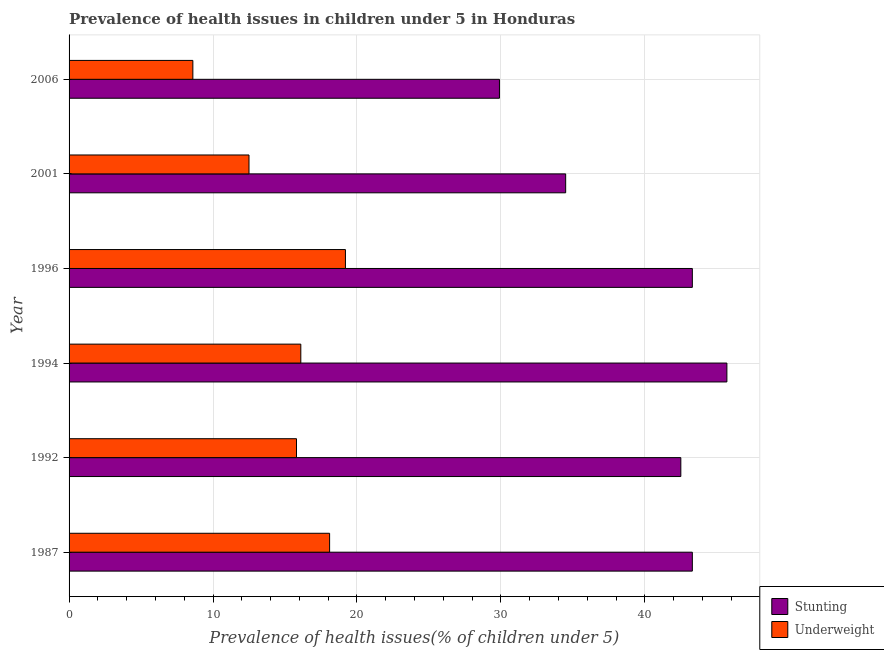Are the number of bars on each tick of the Y-axis equal?
Your answer should be very brief. Yes. How many bars are there on the 4th tick from the top?
Give a very brief answer. 2. How many bars are there on the 6th tick from the bottom?
Offer a very short reply. 2. What is the label of the 2nd group of bars from the top?
Give a very brief answer. 2001. What is the percentage of stunted children in 1987?
Make the answer very short. 43.3. Across all years, what is the maximum percentage of stunted children?
Make the answer very short. 45.7. Across all years, what is the minimum percentage of stunted children?
Provide a succinct answer. 29.9. In which year was the percentage of stunted children maximum?
Provide a succinct answer. 1994. What is the total percentage of underweight children in the graph?
Your answer should be compact. 90.3. What is the difference between the percentage of stunted children in 1996 and the percentage of underweight children in 1987?
Give a very brief answer. 25.2. What is the average percentage of stunted children per year?
Provide a short and direct response. 39.87. In the year 1996, what is the difference between the percentage of stunted children and percentage of underweight children?
Offer a very short reply. 24.1. In how many years, is the percentage of stunted children greater than 32 %?
Make the answer very short. 5. What is the ratio of the percentage of underweight children in 1987 to that in 1994?
Provide a succinct answer. 1.12. Is the difference between the percentage of stunted children in 1987 and 2001 greater than the difference between the percentage of underweight children in 1987 and 2001?
Make the answer very short. Yes. Is the sum of the percentage of underweight children in 1992 and 1994 greater than the maximum percentage of stunted children across all years?
Your response must be concise. No. What does the 1st bar from the top in 1987 represents?
Provide a succinct answer. Underweight. What does the 2nd bar from the bottom in 1987 represents?
Your response must be concise. Underweight. How many years are there in the graph?
Provide a succinct answer. 6. What is the difference between two consecutive major ticks on the X-axis?
Provide a short and direct response. 10. Are the values on the major ticks of X-axis written in scientific E-notation?
Offer a very short reply. No. Does the graph contain grids?
Your answer should be very brief. Yes. Where does the legend appear in the graph?
Keep it short and to the point. Bottom right. How many legend labels are there?
Offer a terse response. 2. How are the legend labels stacked?
Offer a very short reply. Vertical. What is the title of the graph?
Give a very brief answer. Prevalence of health issues in children under 5 in Honduras. What is the label or title of the X-axis?
Make the answer very short. Prevalence of health issues(% of children under 5). What is the label or title of the Y-axis?
Offer a very short reply. Year. What is the Prevalence of health issues(% of children under 5) in Stunting in 1987?
Your response must be concise. 43.3. What is the Prevalence of health issues(% of children under 5) in Underweight in 1987?
Offer a terse response. 18.1. What is the Prevalence of health issues(% of children under 5) of Stunting in 1992?
Give a very brief answer. 42.5. What is the Prevalence of health issues(% of children under 5) in Underweight in 1992?
Offer a terse response. 15.8. What is the Prevalence of health issues(% of children under 5) of Stunting in 1994?
Your response must be concise. 45.7. What is the Prevalence of health issues(% of children under 5) in Underweight in 1994?
Provide a succinct answer. 16.1. What is the Prevalence of health issues(% of children under 5) in Stunting in 1996?
Keep it short and to the point. 43.3. What is the Prevalence of health issues(% of children under 5) in Underweight in 1996?
Provide a short and direct response. 19.2. What is the Prevalence of health issues(% of children under 5) of Stunting in 2001?
Keep it short and to the point. 34.5. What is the Prevalence of health issues(% of children under 5) of Stunting in 2006?
Provide a short and direct response. 29.9. What is the Prevalence of health issues(% of children under 5) of Underweight in 2006?
Make the answer very short. 8.6. Across all years, what is the maximum Prevalence of health issues(% of children under 5) in Stunting?
Provide a succinct answer. 45.7. Across all years, what is the maximum Prevalence of health issues(% of children under 5) in Underweight?
Offer a terse response. 19.2. Across all years, what is the minimum Prevalence of health issues(% of children under 5) in Stunting?
Offer a terse response. 29.9. Across all years, what is the minimum Prevalence of health issues(% of children under 5) in Underweight?
Provide a succinct answer. 8.6. What is the total Prevalence of health issues(% of children under 5) in Stunting in the graph?
Provide a succinct answer. 239.2. What is the total Prevalence of health issues(% of children under 5) of Underweight in the graph?
Keep it short and to the point. 90.3. What is the difference between the Prevalence of health issues(% of children under 5) in Stunting in 1987 and that in 1996?
Your answer should be very brief. 0. What is the difference between the Prevalence of health issues(% of children under 5) of Underweight in 1992 and that in 1994?
Provide a succinct answer. -0.3. What is the difference between the Prevalence of health issues(% of children under 5) in Stunting in 1992 and that in 1996?
Ensure brevity in your answer.  -0.8. What is the difference between the Prevalence of health issues(% of children under 5) of Stunting in 1992 and that in 2001?
Offer a terse response. 8. What is the difference between the Prevalence of health issues(% of children under 5) of Underweight in 1992 and that in 2006?
Offer a terse response. 7.2. What is the difference between the Prevalence of health issues(% of children under 5) of Stunting in 1994 and that in 2001?
Keep it short and to the point. 11.2. What is the difference between the Prevalence of health issues(% of children under 5) in Underweight in 1994 and that in 2006?
Keep it short and to the point. 7.5. What is the difference between the Prevalence of health issues(% of children under 5) of Stunting in 1996 and that in 2001?
Make the answer very short. 8.8. What is the difference between the Prevalence of health issues(% of children under 5) of Underweight in 1996 and that in 2001?
Give a very brief answer. 6.7. What is the difference between the Prevalence of health issues(% of children under 5) in Stunting in 2001 and that in 2006?
Your response must be concise. 4.6. What is the difference between the Prevalence of health issues(% of children under 5) of Stunting in 1987 and the Prevalence of health issues(% of children under 5) of Underweight in 1994?
Your answer should be compact. 27.2. What is the difference between the Prevalence of health issues(% of children under 5) in Stunting in 1987 and the Prevalence of health issues(% of children under 5) in Underweight in 1996?
Provide a short and direct response. 24.1. What is the difference between the Prevalence of health issues(% of children under 5) of Stunting in 1987 and the Prevalence of health issues(% of children under 5) of Underweight in 2001?
Offer a terse response. 30.8. What is the difference between the Prevalence of health issues(% of children under 5) of Stunting in 1987 and the Prevalence of health issues(% of children under 5) of Underweight in 2006?
Make the answer very short. 34.7. What is the difference between the Prevalence of health issues(% of children under 5) in Stunting in 1992 and the Prevalence of health issues(% of children under 5) in Underweight in 1994?
Offer a very short reply. 26.4. What is the difference between the Prevalence of health issues(% of children under 5) of Stunting in 1992 and the Prevalence of health issues(% of children under 5) of Underweight in 1996?
Your answer should be compact. 23.3. What is the difference between the Prevalence of health issues(% of children under 5) in Stunting in 1992 and the Prevalence of health issues(% of children under 5) in Underweight in 2006?
Give a very brief answer. 33.9. What is the difference between the Prevalence of health issues(% of children under 5) in Stunting in 1994 and the Prevalence of health issues(% of children under 5) in Underweight in 2001?
Give a very brief answer. 33.2. What is the difference between the Prevalence of health issues(% of children under 5) in Stunting in 1994 and the Prevalence of health issues(% of children under 5) in Underweight in 2006?
Make the answer very short. 37.1. What is the difference between the Prevalence of health issues(% of children under 5) in Stunting in 1996 and the Prevalence of health issues(% of children under 5) in Underweight in 2001?
Your response must be concise. 30.8. What is the difference between the Prevalence of health issues(% of children under 5) of Stunting in 1996 and the Prevalence of health issues(% of children under 5) of Underweight in 2006?
Your answer should be compact. 34.7. What is the difference between the Prevalence of health issues(% of children under 5) of Stunting in 2001 and the Prevalence of health issues(% of children under 5) of Underweight in 2006?
Your answer should be very brief. 25.9. What is the average Prevalence of health issues(% of children under 5) of Stunting per year?
Ensure brevity in your answer.  39.87. What is the average Prevalence of health issues(% of children under 5) in Underweight per year?
Make the answer very short. 15.05. In the year 1987, what is the difference between the Prevalence of health issues(% of children under 5) of Stunting and Prevalence of health issues(% of children under 5) of Underweight?
Keep it short and to the point. 25.2. In the year 1992, what is the difference between the Prevalence of health issues(% of children under 5) of Stunting and Prevalence of health issues(% of children under 5) of Underweight?
Give a very brief answer. 26.7. In the year 1994, what is the difference between the Prevalence of health issues(% of children under 5) in Stunting and Prevalence of health issues(% of children under 5) in Underweight?
Give a very brief answer. 29.6. In the year 1996, what is the difference between the Prevalence of health issues(% of children under 5) of Stunting and Prevalence of health issues(% of children under 5) of Underweight?
Give a very brief answer. 24.1. In the year 2001, what is the difference between the Prevalence of health issues(% of children under 5) of Stunting and Prevalence of health issues(% of children under 5) of Underweight?
Ensure brevity in your answer.  22. In the year 2006, what is the difference between the Prevalence of health issues(% of children under 5) of Stunting and Prevalence of health issues(% of children under 5) of Underweight?
Keep it short and to the point. 21.3. What is the ratio of the Prevalence of health issues(% of children under 5) in Stunting in 1987 to that in 1992?
Offer a very short reply. 1.02. What is the ratio of the Prevalence of health issues(% of children under 5) of Underweight in 1987 to that in 1992?
Your response must be concise. 1.15. What is the ratio of the Prevalence of health issues(% of children under 5) of Stunting in 1987 to that in 1994?
Your answer should be very brief. 0.95. What is the ratio of the Prevalence of health issues(% of children under 5) in Underweight in 1987 to that in 1994?
Your response must be concise. 1.12. What is the ratio of the Prevalence of health issues(% of children under 5) in Stunting in 1987 to that in 1996?
Keep it short and to the point. 1. What is the ratio of the Prevalence of health issues(% of children under 5) in Underweight in 1987 to that in 1996?
Provide a short and direct response. 0.94. What is the ratio of the Prevalence of health issues(% of children under 5) of Stunting in 1987 to that in 2001?
Keep it short and to the point. 1.26. What is the ratio of the Prevalence of health issues(% of children under 5) in Underweight in 1987 to that in 2001?
Your answer should be very brief. 1.45. What is the ratio of the Prevalence of health issues(% of children under 5) of Stunting in 1987 to that in 2006?
Offer a terse response. 1.45. What is the ratio of the Prevalence of health issues(% of children under 5) of Underweight in 1987 to that in 2006?
Keep it short and to the point. 2.1. What is the ratio of the Prevalence of health issues(% of children under 5) in Stunting in 1992 to that in 1994?
Provide a short and direct response. 0.93. What is the ratio of the Prevalence of health issues(% of children under 5) of Underweight in 1992 to that in 1994?
Offer a very short reply. 0.98. What is the ratio of the Prevalence of health issues(% of children under 5) of Stunting in 1992 to that in 1996?
Give a very brief answer. 0.98. What is the ratio of the Prevalence of health issues(% of children under 5) in Underweight in 1992 to that in 1996?
Provide a short and direct response. 0.82. What is the ratio of the Prevalence of health issues(% of children under 5) of Stunting in 1992 to that in 2001?
Provide a succinct answer. 1.23. What is the ratio of the Prevalence of health issues(% of children under 5) of Underweight in 1992 to that in 2001?
Your response must be concise. 1.26. What is the ratio of the Prevalence of health issues(% of children under 5) in Stunting in 1992 to that in 2006?
Provide a succinct answer. 1.42. What is the ratio of the Prevalence of health issues(% of children under 5) of Underweight in 1992 to that in 2006?
Your response must be concise. 1.84. What is the ratio of the Prevalence of health issues(% of children under 5) of Stunting in 1994 to that in 1996?
Your response must be concise. 1.06. What is the ratio of the Prevalence of health issues(% of children under 5) of Underweight in 1994 to that in 1996?
Your answer should be very brief. 0.84. What is the ratio of the Prevalence of health issues(% of children under 5) in Stunting in 1994 to that in 2001?
Keep it short and to the point. 1.32. What is the ratio of the Prevalence of health issues(% of children under 5) of Underweight in 1994 to that in 2001?
Provide a succinct answer. 1.29. What is the ratio of the Prevalence of health issues(% of children under 5) in Stunting in 1994 to that in 2006?
Keep it short and to the point. 1.53. What is the ratio of the Prevalence of health issues(% of children under 5) of Underweight in 1994 to that in 2006?
Provide a succinct answer. 1.87. What is the ratio of the Prevalence of health issues(% of children under 5) in Stunting in 1996 to that in 2001?
Your answer should be compact. 1.26. What is the ratio of the Prevalence of health issues(% of children under 5) of Underweight in 1996 to that in 2001?
Offer a terse response. 1.54. What is the ratio of the Prevalence of health issues(% of children under 5) of Stunting in 1996 to that in 2006?
Provide a short and direct response. 1.45. What is the ratio of the Prevalence of health issues(% of children under 5) in Underweight in 1996 to that in 2006?
Your answer should be compact. 2.23. What is the ratio of the Prevalence of health issues(% of children under 5) in Stunting in 2001 to that in 2006?
Provide a short and direct response. 1.15. What is the ratio of the Prevalence of health issues(% of children under 5) in Underweight in 2001 to that in 2006?
Provide a short and direct response. 1.45. What is the difference between the highest and the lowest Prevalence of health issues(% of children under 5) of Stunting?
Your response must be concise. 15.8. 